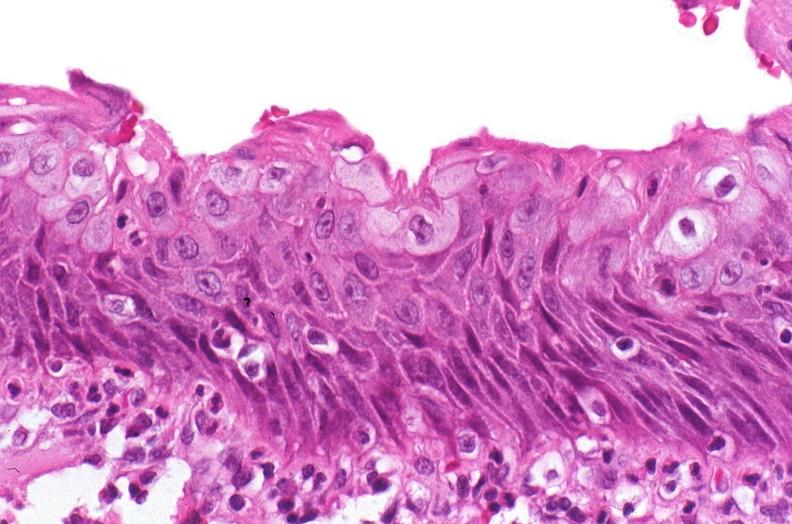s urinary present?
Answer the question using a single word or phrase. Yes 